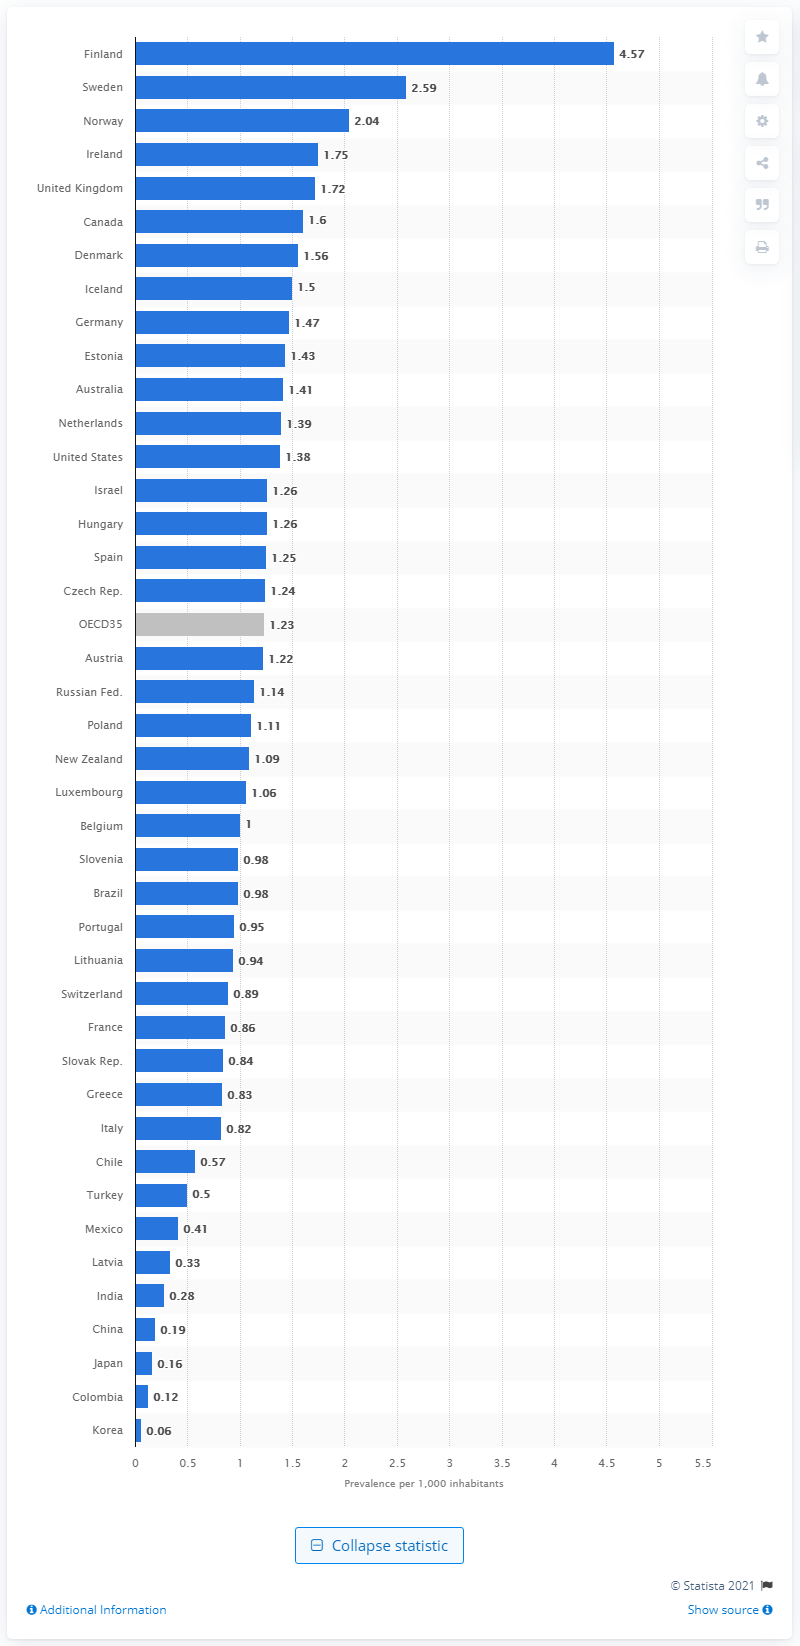Specify some key components in this picture. As of 2015, there were 4.57 cases of type 1 diabetes per 1,000 inhabitants in Finland. 